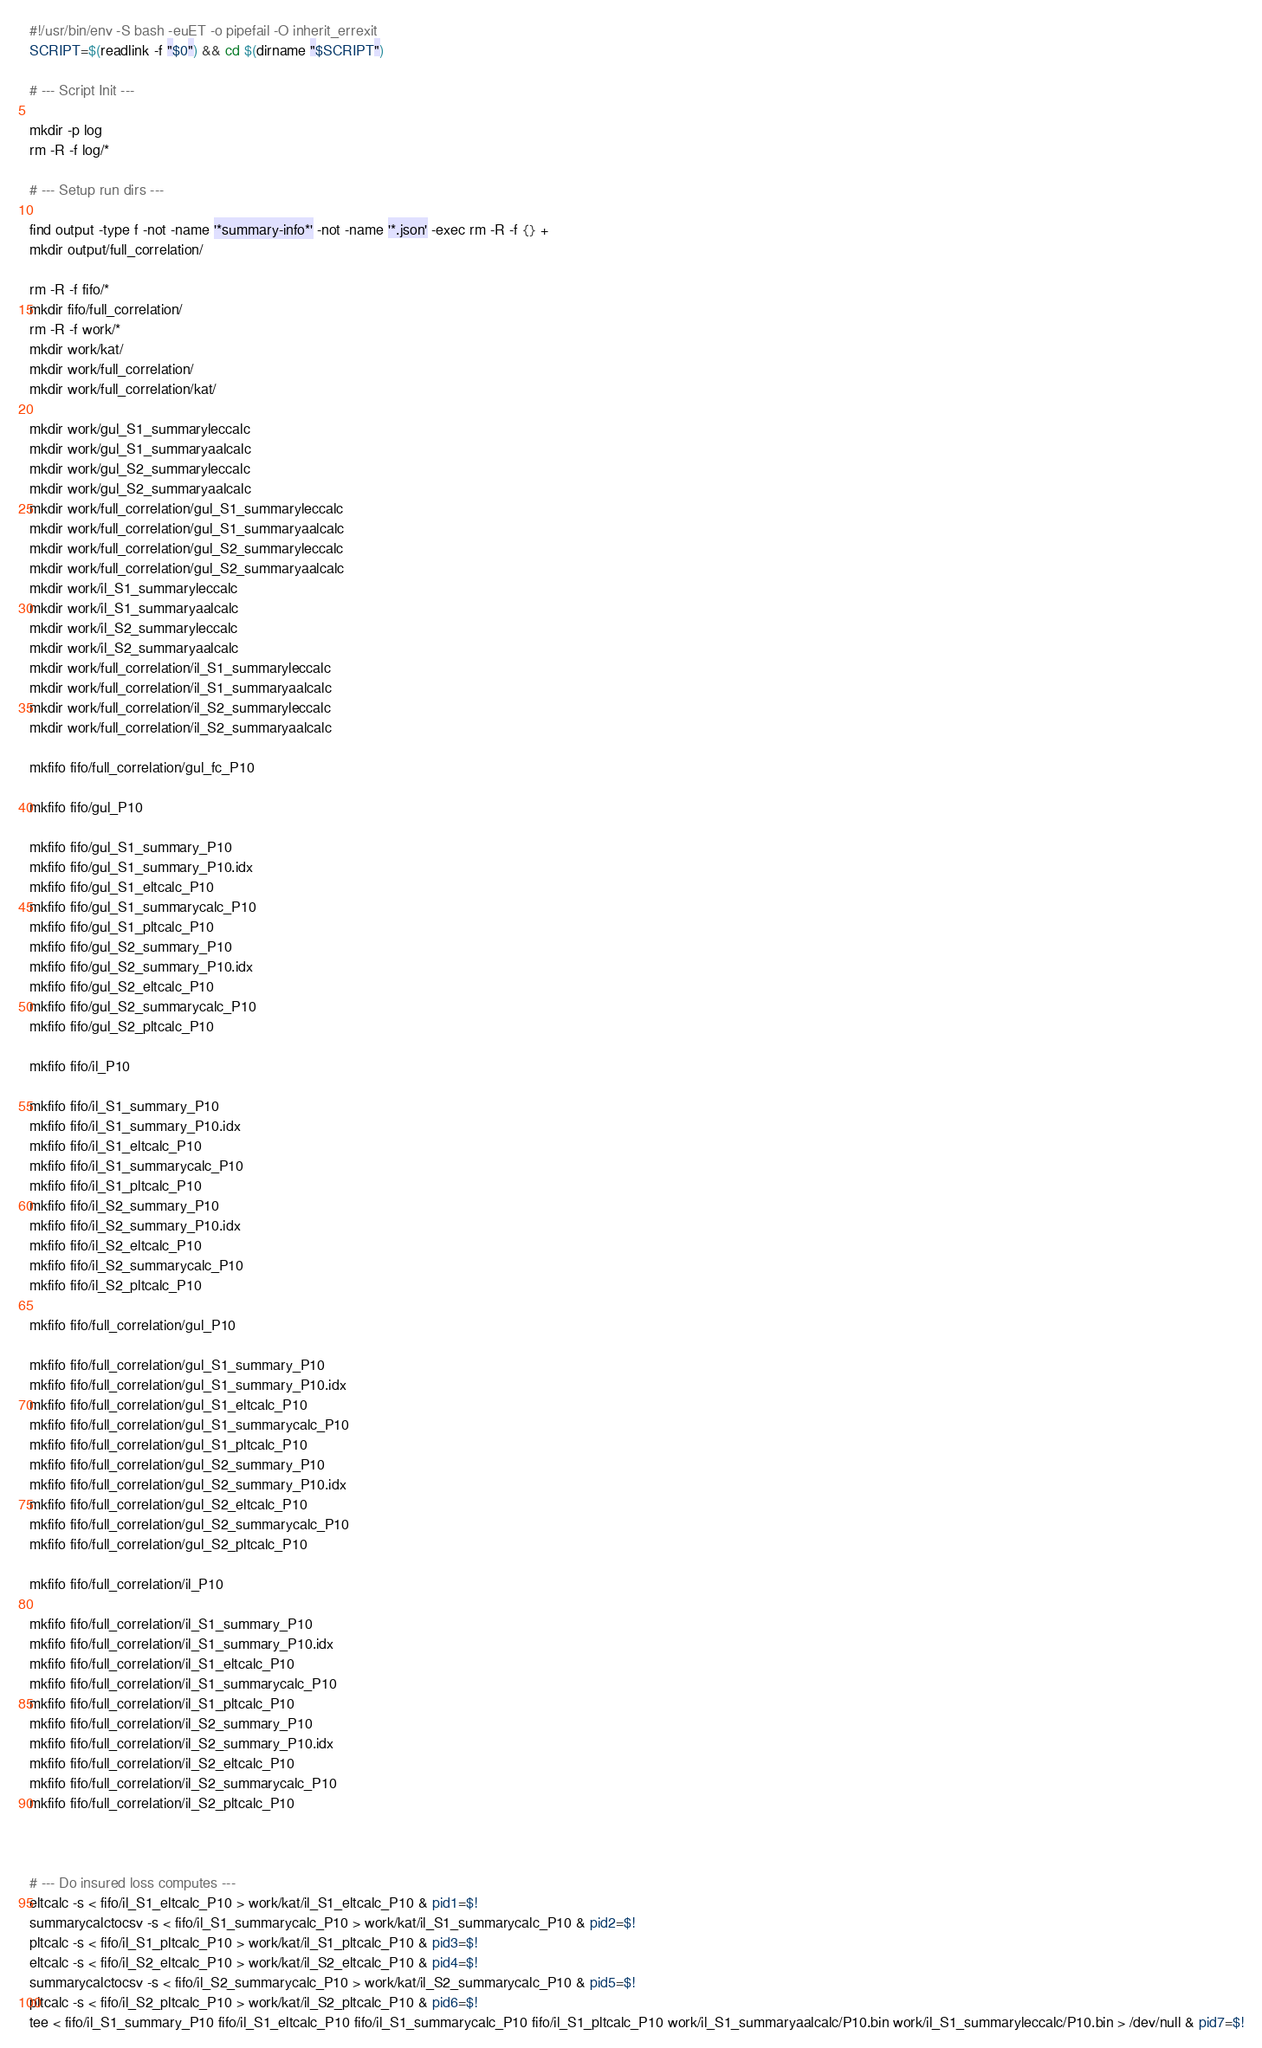Convert code to text. <code><loc_0><loc_0><loc_500><loc_500><_Bash_>#!/usr/bin/env -S bash -euET -o pipefail -O inherit_errexit
SCRIPT=$(readlink -f "$0") && cd $(dirname "$SCRIPT")

# --- Script Init ---

mkdir -p log
rm -R -f log/*

# --- Setup run dirs ---

find output -type f -not -name '*summary-info*' -not -name '*.json' -exec rm -R -f {} +
mkdir output/full_correlation/

rm -R -f fifo/*
mkdir fifo/full_correlation/
rm -R -f work/*
mkdir work/kat/
mkdir work/full_correlation/
mkdir work/full_correlation/kat/

mkdir work/gul_S1_summaryleccalc
mkdir work/gul_S1_summaryaalcalc
mkdir work/gul_S2_summaryleccalc
mkdir work/gul_S2_summaryaalcalc
mkdir work/full_correlation/gul_S1_summaryleccalc
mkdir work/full_correlation/gul_S1_summaryaalcalc
mkdir work/full_correlation/gul_S2_summaryleccalc
mkdir work/full_correlation/gul_S2_summaryaalcalc
mkdir work/il_S1_summaryleccalc
mkdir work/il_S1_summaryaalcalc
mkdir work/il_S2_summaryleccalc
mkdir work/il_S2_summaryaalcalc
mkdir work/full_correlation/il_S1_summaryleccalc
mkdir work/full_correlation/il_S1_summaryaalcalc
mkdir work/full_correlation/il_S2_summaryleccalc
mkdir work/full_correlation/il_S2_summaryaalcalc

mkfifo fifo/full_correlation/gul_fc_P10

mkfifo fifo/gul_P10

mkfifo fifo/gul_S1_summary_P10
mkfifo fifo/gul_S1_summary_P10.idx
mkfifo fifo/gul_S1_eltcalc_P10
mkfifo fifo/gul_S1_summarycalc_P10
mkfifo fifo/gul_S1_pltcalc_P10
mkfifo fifo/gul_S2_summary_P10
mkfifo fifo/gul_S2_summary_P10.idx
mkfifo fifo/gul_S2_eltcalc_P10
mkfifo fifo/gul_S2_summarycalc_P10
mkfifo fifo/gul_S2_pltcalc_P10

mkfifo fifo/il_P10

mkfifo fifo/il_S1_summary_P10
mkfifo fifo/il_S1_summary_P10.idx
mkfifo fifo/il_S1_eltcalc_P10
mkfifo fifo/il_S1_summarycalc_P10
mkfifo fifo/il_S1_pltcalc_P10
mkfifo fifo/il_S2_summary_P10
mkfifo fifo/il_S2_summary_P10.idx
mkfifo fifo/il_S2_eltcalc_P10
mkfifo fifo/il_S2_summarycalc_P10
mkfifo fifo/il_S2_pltcalc_P10

mkfifo fifo/full_correlation/gul_P10

mkfifo fifo/full_correlation/gul_S1_summary_P10
mkfifo fifo/full_correlation/gul_S1_summary_P10.idx
mkfifo fifo/full_correlation/gul_S1_eltcalc_P10
mkfifo fifo/full_correlation/gul_S1_summarycalc_P10
mkfifo fifo/full_correlation/gul_S1_pltcalc_P10
mkfifo fifo/full_correlation/gul_S2_summary_P10
mkfifo fifo/full_correlation/gul_S2_summary_P10.idx
mkfifo fifo/full_correlation/gul_S2_eltcalc_P10
mkfifo fifo/full_correlation/gul_S2_summarycalc_P10
mkfifo fifo/full_correlation/gul_S2_pltcalc_P10

mkfifo fifo/full_correlation/il_P10

mkfifo fifo/full_correlation/il_S1_summary_P10
mkfifo fifo/full_correlation/il_S1_summary_P10.idx
mkfifo fifo/full_correlation/il_S1_eltcalc_P10
mkfifo fifo/full_correlation/il_S1_summarycalc_P10
mkfifo fifo/full_correlation/il_S1_pltcalc_P10
mkfifo fifo/full_correlation/il_S2_summary_P10
mkfifo fifo/full_correlation/il_S2_summary_P10.idx
mkfifo fifo/full_correlation/il_S2_eltcalc_P10
mkfifo fifo/full_correlation/il_S2_summarycalc_P10
mkfifo fifo/full_correlation/il_S2_pltcalc_P10



# --- Do insured loss computes ---
eltcalc -s < fifo/il_S1_eltcalc_P10 > work/kat/il_S1_eltcalc_P10 & pid1=$!
summarycalctocsv -s < fifo/il_S1_summarycalc_P10 > work/kat/il_S1_summarycalc_P10 & pid2=$!
pltcalc -s < fifo/il_S1_pltcalc_P10 > work/kat/il_S1_pltcalc_P10 & pid3=$!
eltcalc -s < fifo/il_S2_eltcalc_P10 > work/kat/il_S2_eltcalc_P10 & pid4=$!
summarycalctocsv -s < fifo/il_S2_summarycalc_P10 > work/kat/il_S2_summarycalc_P10 & pid5=$!
pltcalc -s < fifo/il_S2_pltcalc_P10 > work/kat/il_S2_pltcalc_P10 & pid6=$!
tee < fifo/il_S1_summary_P10 fifo/il_S1_eltcalc_P10 fifo/il_S1_summarycalc_P10 fifo/il_S1_pltcalc_P10 work/il_S1_summaryaalcalc/P10.bin work/il_S1_summaryleccalc/P10.bin > /dev/null & pid7=$!</code> 